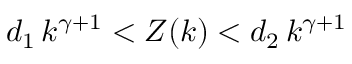Convert formula to latex. <formula><loc_0><loc_0><loc_500><loc_500>d _ { 1 } \, k ^ { \gamma + 1 } < Z ( k ) < d _ { 2 } \, k ^ { \gamma + 1 }</formula> 